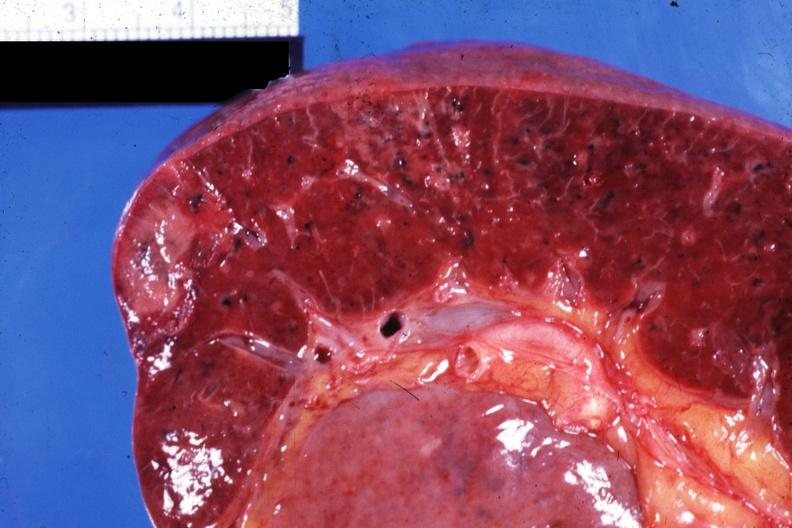s this present?
Answer the question using a single word or phrase. No 